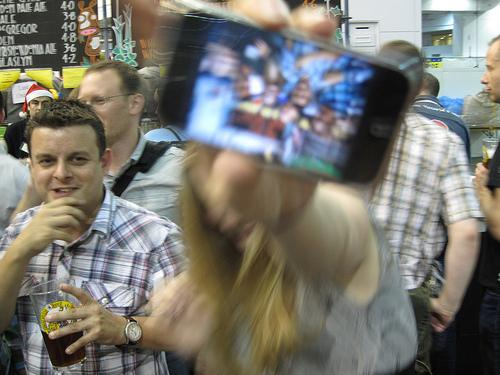Describe the interaction between the man and the glass he is holding. The man is holding a drinking glass with a yellow decal in his hand. Identify the primary action happening in the image. A girl is holding up her phone to take a selfie. Count the number of people in the image and mention one specific object that one of them is holding. There are two people in the image, and one of them is holding a beer glass. What is the content of the board in the image, and where is it placed? The board shows the alcohol content of beers and is placed in the top left corner of the image. Explain the appearance and location of the watch in the image. The watch has a big brown face and is located on the left wrist of a man. Explain the appearance of the phone in the image and mention its state. The screen of the phone is moving and blurry, and the phone is powered on. Describe the hair color and style of the individuals in the image. One person has short dark hair, and the other has blonde hair. Name an object in the image that is associated with the holiday season. A man is wearing a Santa Claus hat in the image. What type of shirt is the man wearing, and what is he doing with his hand? The man is wearing a plaid shirt and touching his chin. Mention a specific fashion accessory worn by a man in the image and describe its appearance. A man is wearing eyeglasses with black frames. What type of shirt is the man touching his chin wearing?  Button down shirt What is a distinct aspect of the background in this image? Christmas decorations What activity is the girl with the phone doing? Taking a selfie What decoration does the beer glass have? A yellow decal What is the girl doing in the image? Holding a phone up What unique characteristic does the man with glasses have in his hand? A big brown watch Who is wearing a wristwatch in the image? The man holding a beer glass What type of shirt is the man with the beer glass wearing? Plaid shirt Describe the man wearing a plaid shirt. He has short dark hair, he is touching his chin and wearing glasses. Is the cellphone powered on or off? Powered on What type of hair does the person taking a selfie have? Short blonde hair Who is wearing a Santa hat? A man Identify the type of the board in the image. A chalk board with numbers on it, showing alcohol content of beers. What is the man holding in his hand besides the cell phone? A beer glass with a yellow decal What is the man with glasses touching? His chin Provide a brief description of the scene in this image. A girl taking a selfie with a man wearing a plaid shirt, glasses, a Santa hat, and holding a beer glass with a watch on his wrist. Are there any additional decorations in the back of the image? (Yes/No)  Yes Choose the correct hair color for the person taking a selfie: (a) blonde (b) brown (c) black. (a) blonde 